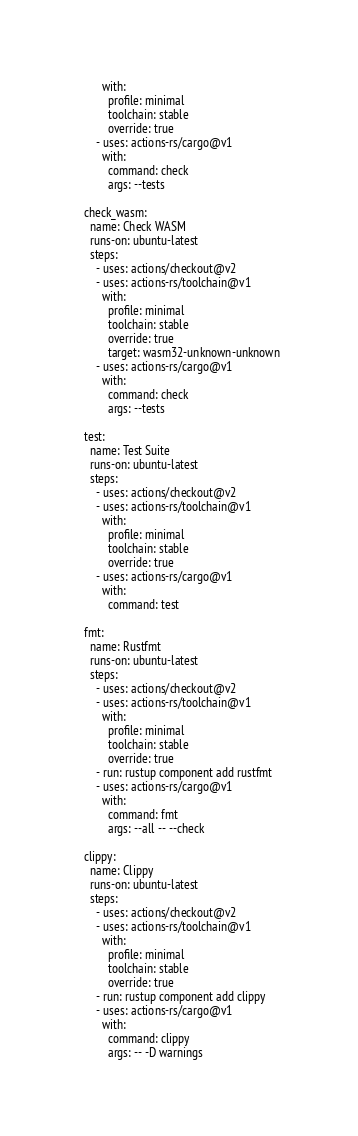Convert code to text. <code><loc_0><loc_0><loc_500><loc_500><_YAML_>        with:
          profile: minimal
          toolchain: stable
          override: true
      - uses: actions-rs/cargo@v1
        with:
          command: check
          args: --tests

  check_wasm:
    name: Check WASM
    runs-on: ubuntu-latest
    steps:
      - uses: actions/checkout@v2
      - uses: actions-rs/toolchain@v1
        with:
          profile: minimal
          toolchain: stable
          override: true
          target: wasm32-unknown-unknown
      - uses: actions-rs/cargo@v1
        with:
          command: check
          args: --tests

  test:
    name: Test Suite
    runs-on: ubuntu-latest
    steps:
      - uses: actions/checkout@v2
      - uses: actions-rs/toolchain@v1
        with:
          profile: minimal
          toolchain: stable
          override: true
      - uses: actions-rs/cargo@v1
        with:
          command: test

  fmt:
    name: Rustfmt
    runs-on: ubuntu-latest
    steps:
      - uses: actions/checkout@v2
      - uses: actions-rs/toolchain@v1
        with:
          profile: minimal
          toolchain: stable
          override: true
      - run: rustup component add rustfmt
      - uses: actions-rs/cargo@v1
        with:
          command: fmt
          args: --all -- --check

  clippy:
    name: Clippy
    runs-on: ubuntu-latest
    steps:
      - uses: actions/checkout@v2
      - uses: actions-rs/toolchain@v1
        with:
          profile: minimal
          toolchain: stable
          override: true
      - run: rustup component add clippy
      - uses: actions-rs/cargo@v1
        with:
          command: clippy
          args: -- -D warnings</code> 